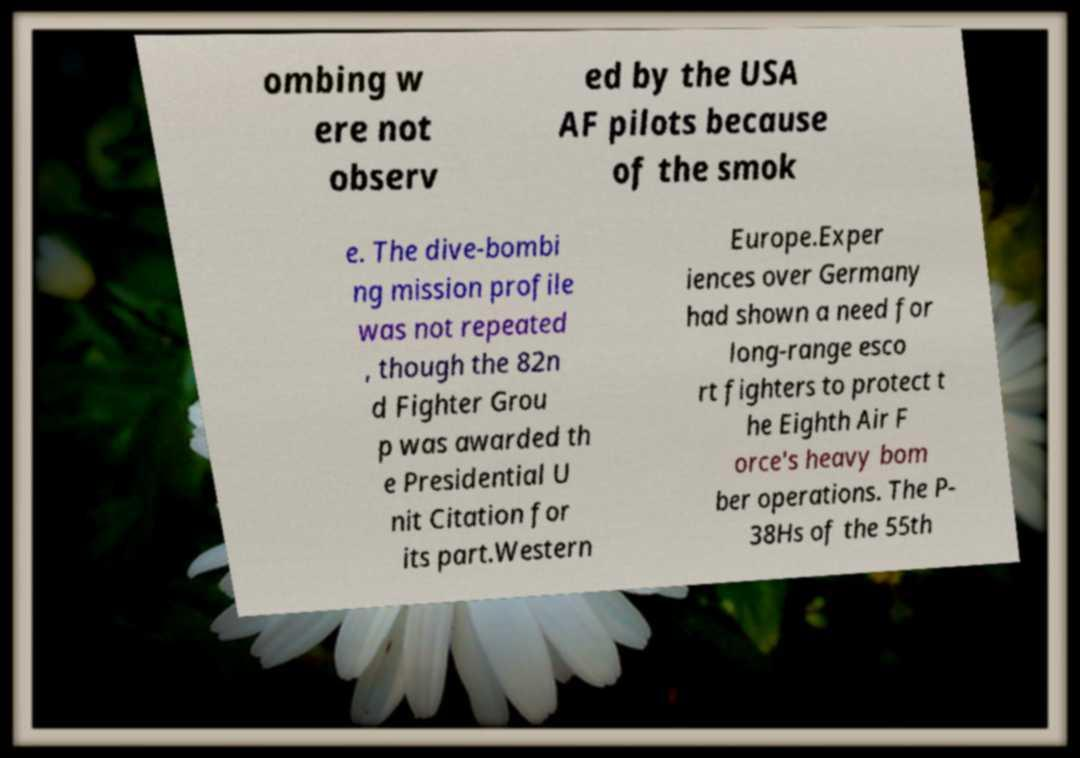Can you read and provide the text displayed in the image?This photo seems to have some interesting text. Can you extract and type it out for me? ombing w ere not observ ed by the USA AF pilots because of the smok e. The dive-bombi ng mission profile was not repeated , though the 82n d Fighter Grou p was awarded th e Presidential U nit Citation for its part.Western Europe.Exper iences over Germany had shown a need for long-range esco rt fighters to protect t he Eighth Air F orce's heavy bom ber operations. The P- 38Hs of the 55th 